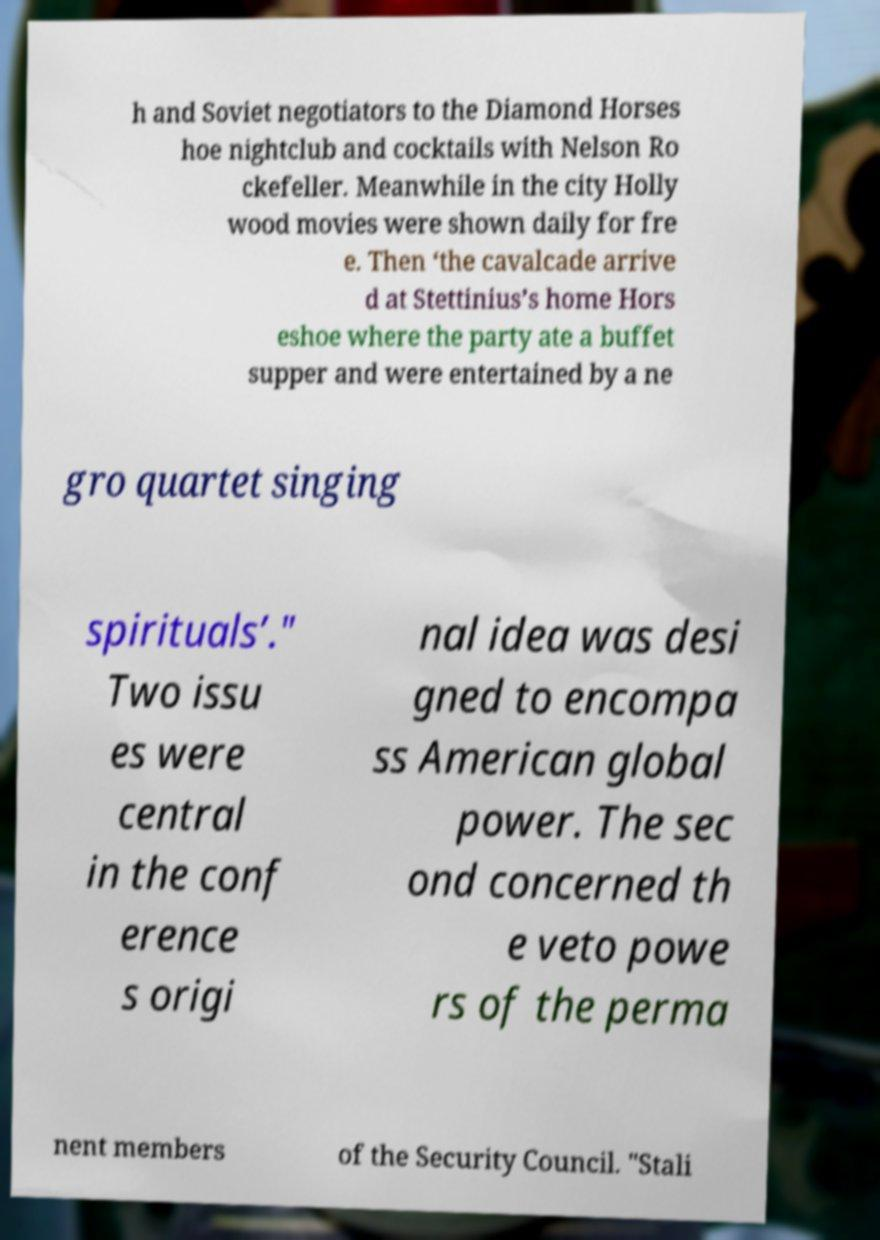For documentation purposes, I need the text within this image transcribed. Could you provide that? h and Soviet negotiators to the Diamond Horses hoe nightclub and cocktails with Nelson Ro ckefeller. Meanwhile in the city Holly wood movies were shown daily for fre e. Then ‘the cavalcade arrive d at Stettinius’s home Hors eshoe where the party ate a buffet supper and were entertained by a ne gro quartet singing spirituals’." Two issu es were central in the conf erence s origi nal idea was desi gned to encompa ss American global power. The sec ond concerned th e veto powe rs of the perma nent members of the Security Council. "Stali 